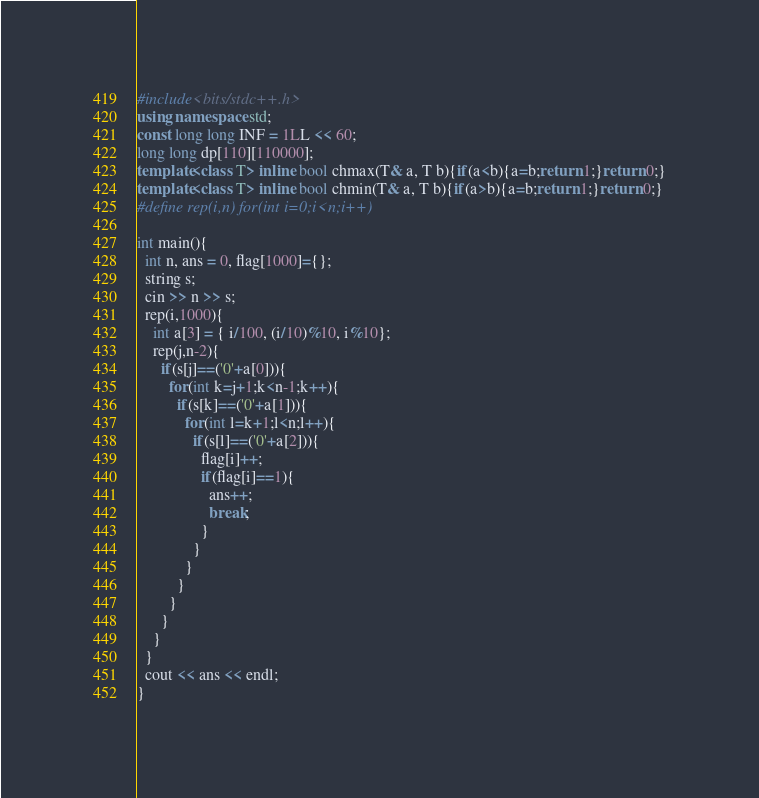<code> <loc_0><loc_0><loc_500><loc_500><_C++_>#include<bits/stdc++.h>
using namespace std;
const long long INF = 1LL << 60;
long long dp[110][110000];
template<class T> inline bool chmax(T& a, T b){if(a<b){a=b;return 1;}return 0;}
template<class T> inline bool chmin(T& a, T b){if(a>b){a=b;return 1;}return 0;}
#define rep(i,n) for(int i=0;i<n;i++)

int main(){
  int n, ans = 0, flag[1000]={};
  string s;
  cin >> n >> s;
  rep(i,1000){
    int a[3] = { i/100, (i/10)%10, i%10};
    rep(j,n-2){
      if(s[j]==('0'+a[0])){
        for(int k=j+1;k<n-1;k++){
          if(s[k]==('0'+a[1])){
            for(int l=k+1;l<n;l++){
              if(s[l]==('0'+a[2])){
                flag[i]++;
                if(flag[i]==1){
                  ans++;
                  break;
                }
              }
            }
          }
        }
      }
    }
  }
  cout << ans << endl;
}
</code> 